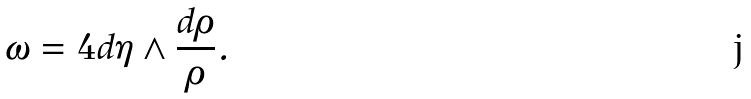<formula> <loc_0><loc_0><loc_500><loc_500>\omega = 4 d \eta \wedge \frac { d \rho } { \rho } .</formula> 